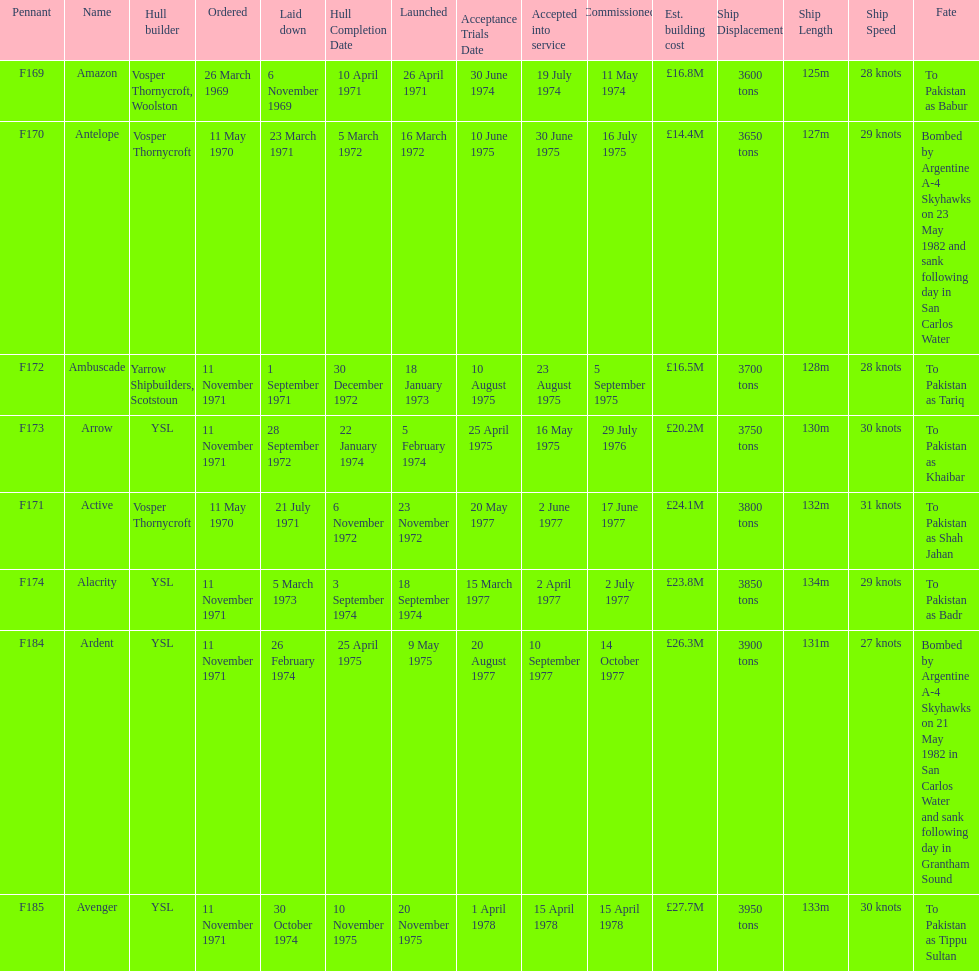Amazon is at the top of the chart, but what is the name below it? Antelope. 